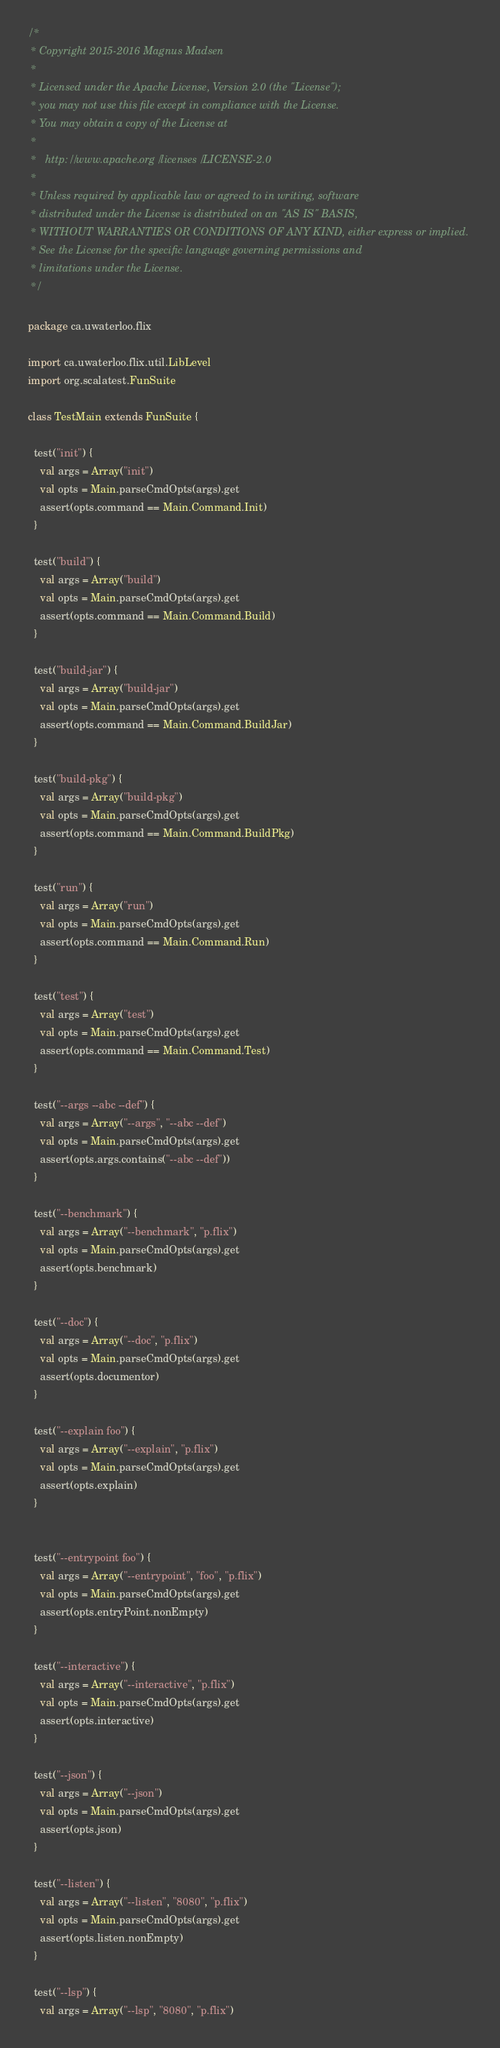Convert code to text. <code><loc_0><loc_0><loc_500><loc_500><_Scala_>/*
 * Copyright 2015-2016 Magnus Madsen
 *
 * Licensed under the Apache License, Version 2.0 (the "License");
 * you may not use this file except in compliance with the License.
 * You may obtain a copy of the License at
 *
 *   http://www.apache.org/licenses/LICENSE-2.0
 *
 * Unless required by applicable law or agreed to in writing, software
 * distributed under the License is distributed on an "AS IS" BASIS,
 * WITHOUT WARRANTIES OR CONDITIONS OF ANY KIND, either express or implied.
 * See the License for the specific language governing permissions and
 * limitations under the License.
 */

package ca.uwaterloo.flix

import ca.uwaterloo.flix.util.LibLevel
import org.scalatest.FunSuite

class TestMain extends FunSuite {

  test("init") {
    val args = Array("init")
    val opts = Main.parseCmdOpts(args).get
    assert(opts.command == Main.Command.Init)
  }

  test("build") {
    val args = Array("build")
    val opts = Main.parseCmdOpts(args).get
    assert(opts.command == Main.Command.Build)
  }

  test("build-jar") {
    val args = Array("build-jar")
    val opts = Main.parseCmdOpts(args).get
    assert(opts.command == Main.Command.BuildJar)
  }

  test("build-pkg") {
    val args = Array("build-pkg")
    val opts = Main.parseCmdOpts(args).get
    assert(opts.command == Main.Command.BuildPkg)
  }

  test("run") {
    val args = Array("run")
    val opts = Main.parseCmdOpts(args).get
    assert(opts.command == Main.Command.Run)
  }

  test("test") {
    val args = Array("test")
    val opts = Main.parseCmdOpts(args).get
    assert(opts.command == Main.Command.Test)
  }

  test("--args --abc --def") {
    val args = Array("--args", "--abc --def")
    val opts = Main.parseCmdOpts(args).get
    assert(opts.args.contains("--abc --def"))
  }

  test("--benchmark") {
    val args = Array("--benchmark", "p.flix")
    val opts = Main.parseCmdOpts(args).get
    assert(opts.benchmark)
  }

  test("--doc") {
    val args = Array("--doc", "p.flix")
    val opts = Main.parseCmdOpts(args).get
    assert(opts.documentor)
  }

  test("--explain foo") {
    val args = Array("--explain", "p.flix")
    val opts = Main.parseCmdOpts(args).get
    assert(opts.explain)
  }


  test("--entrypoint foo") {
    val args = Array("--entrypoint", "foo", "p.flix")
    val opts = Main.parseCmdOpts(args).get
    assert(opts.entryPoint.nonEmpty)
  }

  test("--interactive") {
    val args = Array("--interactive", "p.flix")
    val opts = Main.parseCmdOpts(args).get
    assert(opts.interactive)
  }

  test("--json") {
    val args = Array("--json")
    val opts = Main.parseCmdOpts(args).get
    assert(opts.json)
  }

  test("--listen") {
    val args = Array("--listen", "8080", "p.flix")
    val opts = Main.parseCmdOpts(args).get
    assert(opts.listen.nonEmpty)
  }

  test("--lsp") {
    val args = Array("--lsp", "8080", "p.flix")</code> 